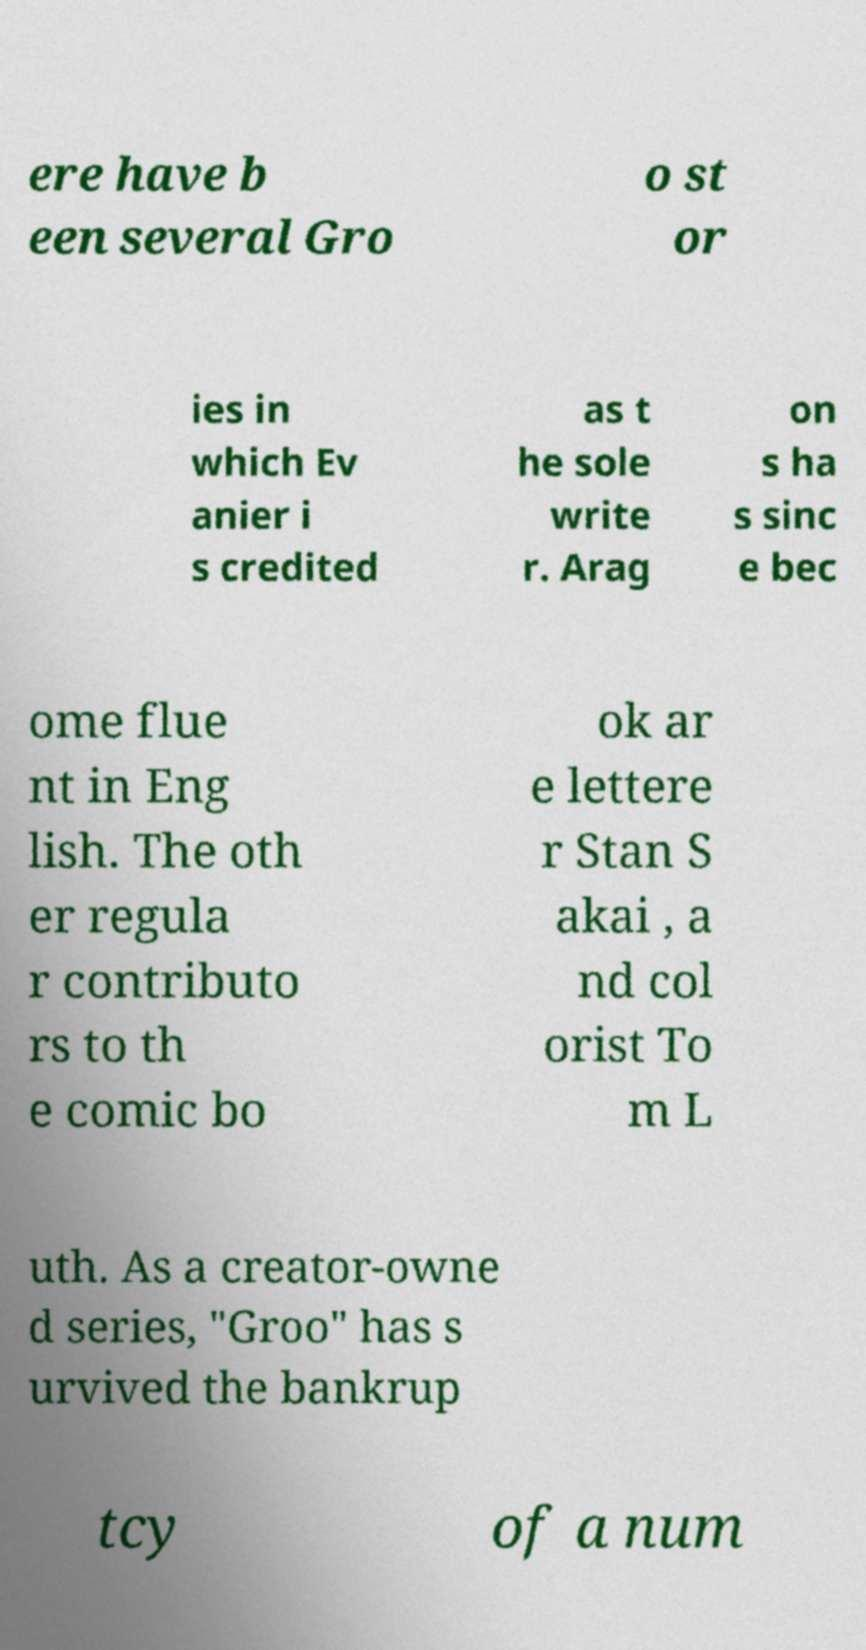I need the written content from this picture converted into text. Can you do that? ere have b een several Gro o st or ies in which Ev anier i s credited as t he sole write r. Arag on s ha s sinc e bec ome flue nt in Eng lish. The oth er regula r contributo rs to th e comic bo ok ar e lettere r Stan S akai , a nd col orist To m L uth. As a creator-owne d series, "Groo" has s urvived the bankrup tcy of a num 